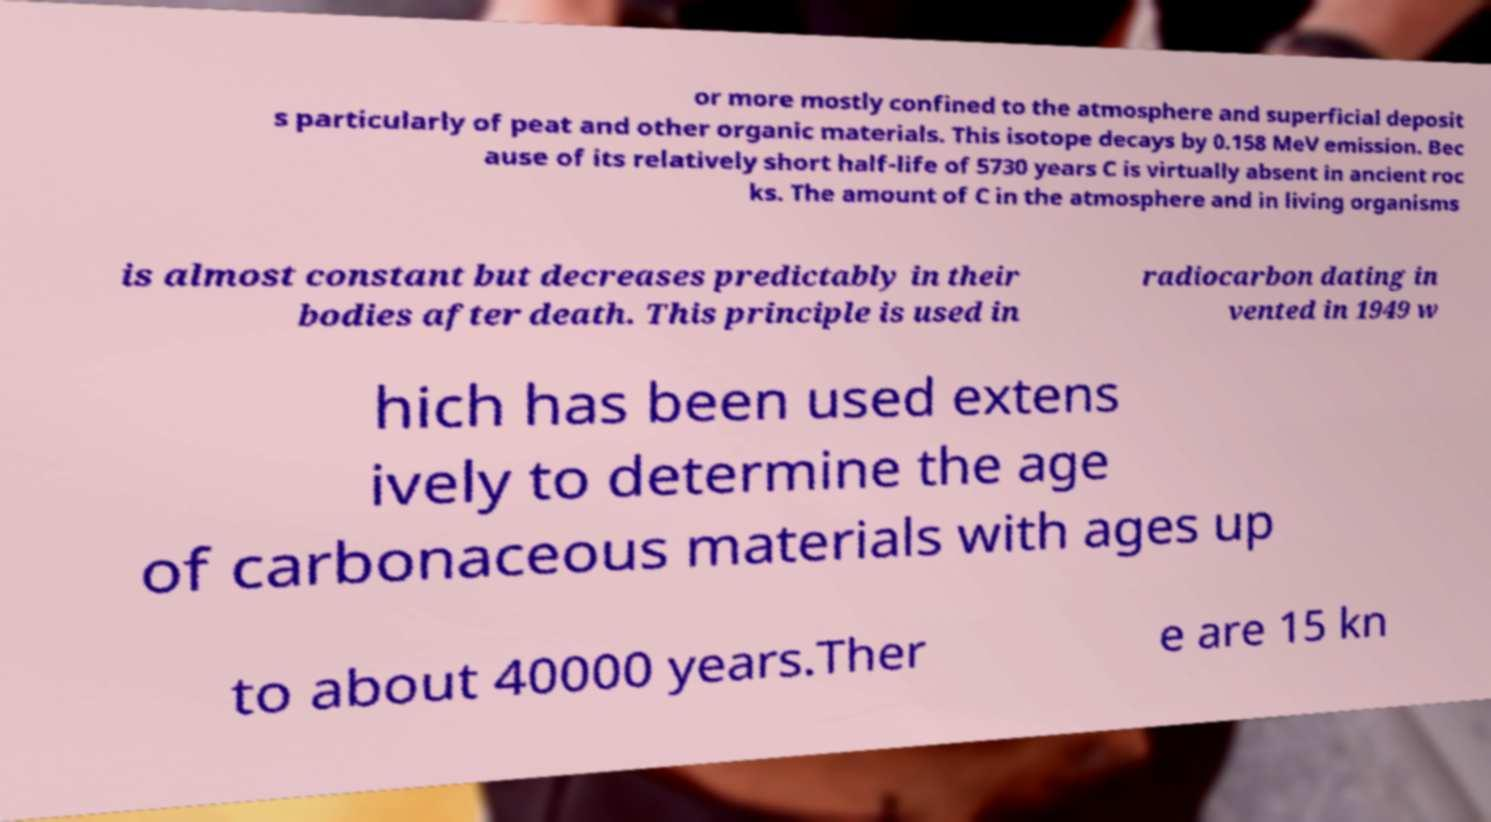What messages or text are displayed in this image? I need them in a readable, typed format. or more mostly confined to the atmosphere and superficial deposit s particularly of peat and other organic materials. This isotope decays by 0.158 MeV emission. Bec ause of its relatively short half-life of 5730 years C is virtually absent in ancient roc ks. The amount of C in the atmosphere and in living organisms is almost constant but decreases predictably in their bodies after death. This principle is used in radiocarbon dating in vented in 1949 w hich has been used extens ively to determine the age of carbonaceous materials with ages up to about 40000 years.Ther e are 15 kn 